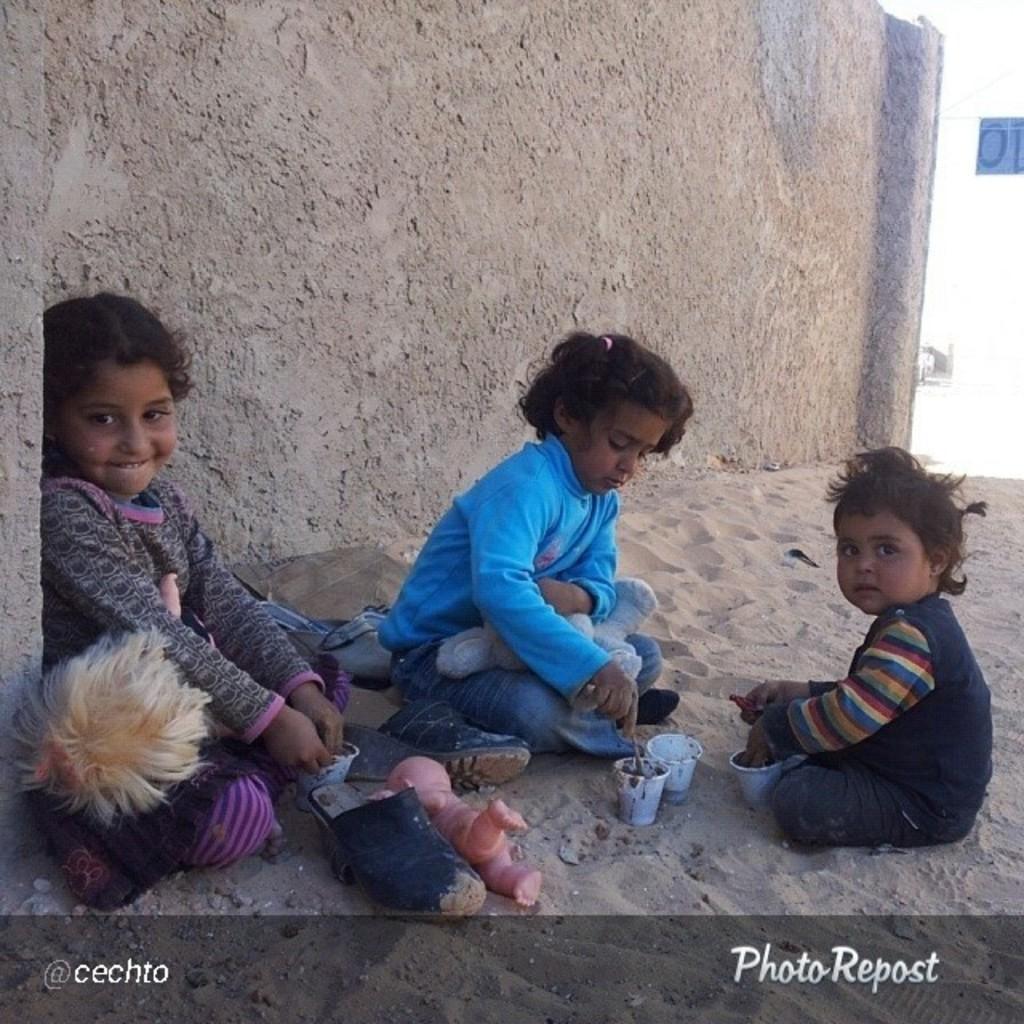In one or two sentences, can you explain what this image depicts? In this image there are three kids sitting on sand, in front of them there are toys, cups, in the background there a wall, at the bottom there is text. 